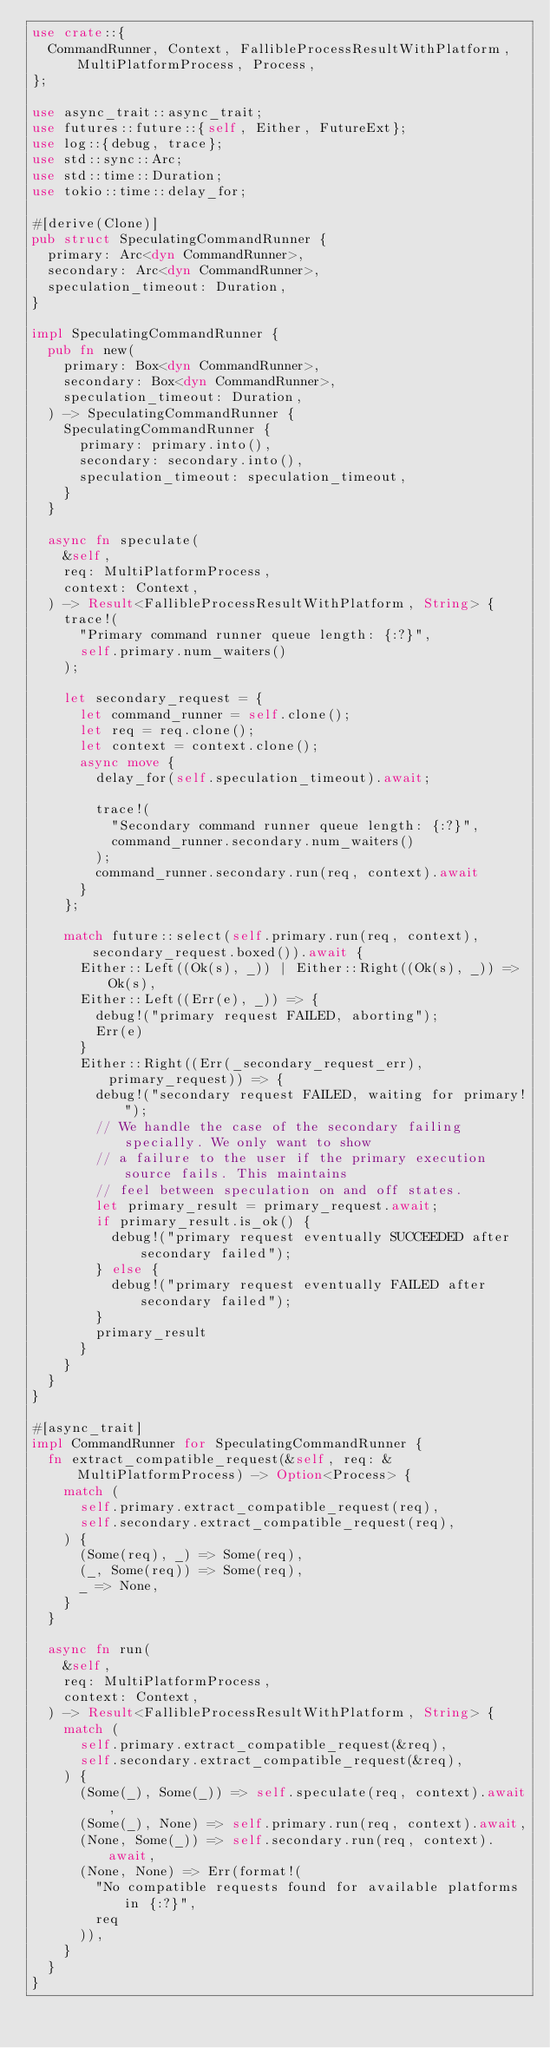Convert code to text. <code><loc_0><loc_0><loc_500><loc_500><_Rust_>use crate::{
  CommandRunner, Context, FallibleProcessResultWithPlatform, MultiPlatformProcess, Process,
};

use async_trait::async_trait;
use futures::future::{self, Either, FutureExt};
use log::{debug, trace};
use std::sync::Arc;
use std::time::Duration;
use tokio::time::delay_for;

#[derive(Clone)]
pub struct SpeculatingCommandRunner {
  primary: Arc<dyn CommandRunner>,
  secondary: Arc<dyn CommandRunner>,
  speculation_timeout: Duration,
}

impl SpeculatingCommandRunner {
  pub fn new(
    primary: Box<dyn CommandRunner>,
    secondary: Box<dyn CommandRunner>,
    speculation_timeout: Duration,
  ) -> SpeculatingCommandRunner {
    SpeculatingCommandRunner {
      primary: primary.into(),
      secondary: secondary.into(),
      speculation_timeout: speculation_timeout,
    }
  }

  async fn speculate(
    &self,
    req: MultiPlatformProcess,
    context: Context,
  ) -> Result<FallibleProcessResultWithPlatform, String> {
    trace!(
      "Primary command runner queue length: {:?}",
      self.primary.num_waiters()
    );

    let secondary_request = {
      let command_runner = self.clone();
      let req = req.clone();
      let context = context.clone();
      async move {
        delay_for(self.speculation_timeout).await;

        trace!(
          "Secondary command runner queue length: {:?}",
          command_runner.secondary.num_waiters()
        );
        command_runner.secondary.run(req, context).await
      }
    };

    match future::select(self.primary.run(req, context), secondary_request.boxed()).await {
      Either::Left((Ok(s), _)) | Either::Right((Ok(s), _)) => Ok(s),
      Either::Left((Err(e), _)) => {
        debug!("primary request FAILED, aborting");
        Err(e)
      }
      Either::Right((Err(_secondary_request_err), primary_request)) => {
        debug!("secondary request FAILED, waiting for primary!");
        // We handle the case of the secondary failing specially. We only want to show
        // a failure to the user if the primary execution source fails. This maintains
        // feel between speculation on and off states.
        let primary_result = primary_request.await;
        if primary_result.is_ok() {
          debug!("primary request eventually SUCCEEDED after secondary failed");
        } else {
          debug!("primary request eventually FAILED after secondary failed");
        }
        primary_result
      }
    }
  }
}

#[async_trait]
impl CommandRunner for SpeculatingCommandRunner {
  fn extract_compatible_request(&self, req: &MultiPlatformProcess) -> Option<Process> {
    match (
      self.primary.extract_compatible_request(req),
      self.secondary.extract_compatible_request(req),
    ) {
      (Some(req), _) => Some(req),
      (_, Some(req)) => Some(req),
      _ => None,
    }
  }

  async fn run(
    &self,
    req: MultiPlatformProcess,
    context: Context,
  ) -> Result<FallibleProcessResultWithPlatform, String> {
    match (
      self.primary.extract_compatible_request(&req),
      self.secondary.extract_compatible_request(&req),
    ) {
      (Some(_), Some(_)) => self.speculate(req, context).await,
      (Some(_), None) => self.primary.run(req, context).await,
      (None, Some(_)) => self.secondary.run(req, context).await,
      (None, None) => Err(format!(
        "No compatible requests found for available platforms in {:?}",
        req
      )),
    }
  }
}
</code> 